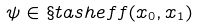<formula> <loc_0><loc_0><loc_500><loc_500>\psi \in \S t a s h e f f ( x _ { 0 } , x _ { 1 } )</formula> 